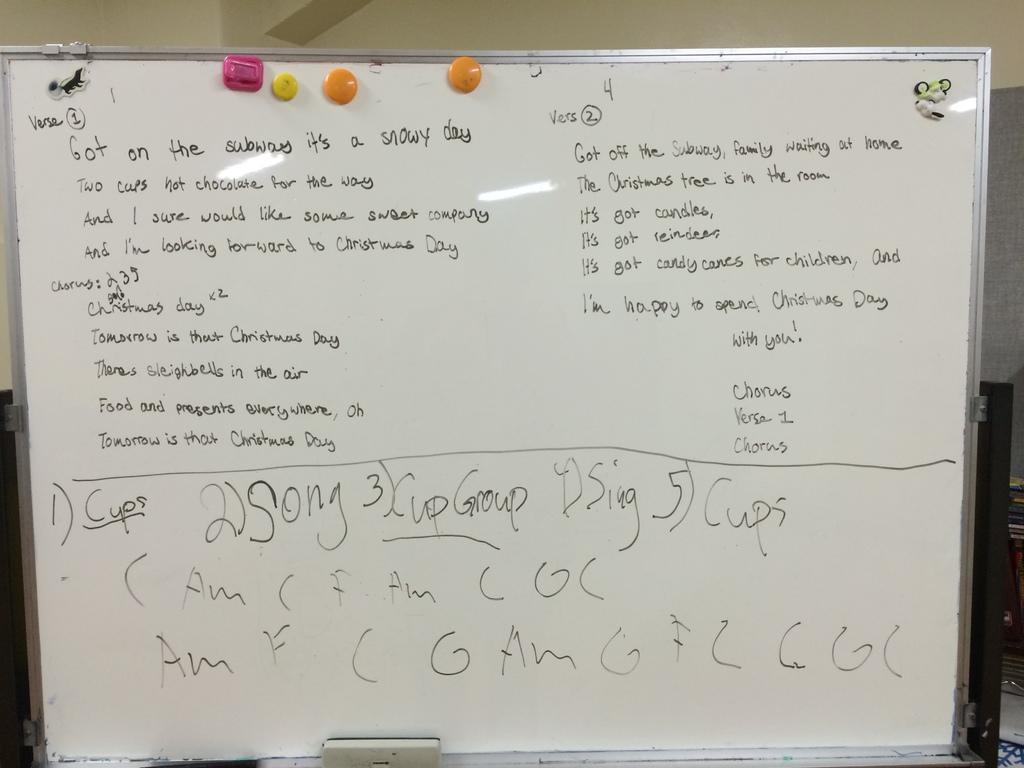<image>
Offer a succinct explanation of the picture presented. A person has written a verse on a white board. 